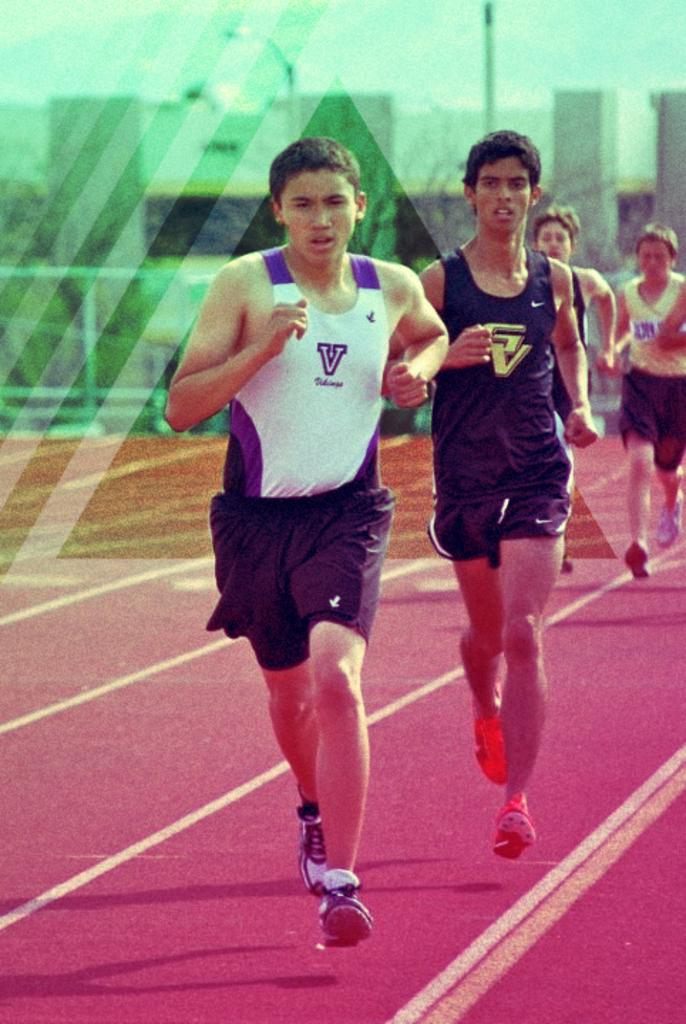Who is present in the image? There are people in the image. What are the people doing? The people are running. What can be seen on the ground in the image? There is a red carpet in the image. What type of map can be seen in the hands of the father in the image? There is no father or map present in the image. How many bubbles are floating around the people in the image? There are no bubbles present in the image. 